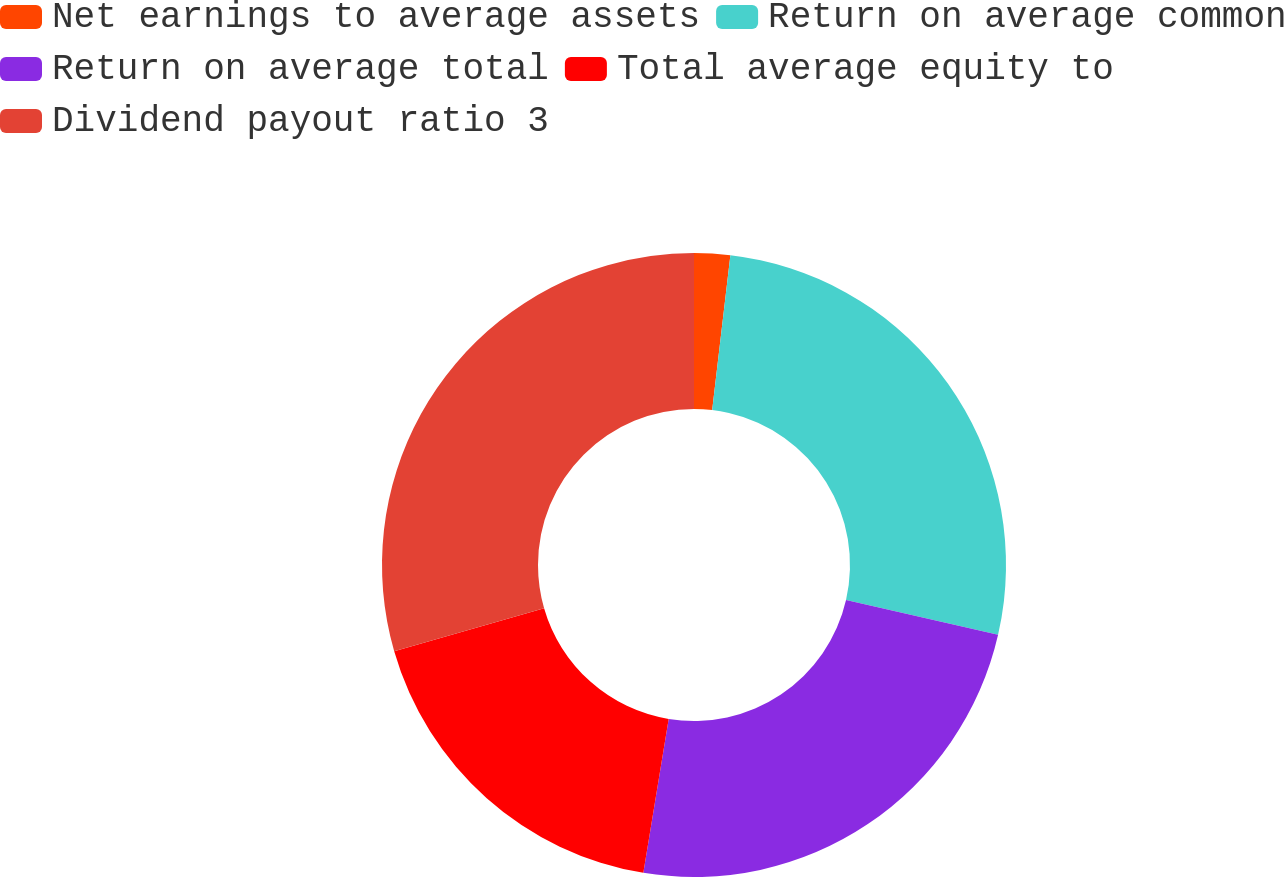Convert chart. <chart><loc_0><loc_0><loc_500><loc_500><pie_chart><fcel>Net earnings to average assets<fcel>Return on average common<fcel>Return on average total<fcel>Total average equity to<fcel>Dividend payout ratio 3<nl><fcel>1.86%<fcel>26.73%<fcel>24.0%<fcel>17.94%<fcel>29.46%<nl></chart> 